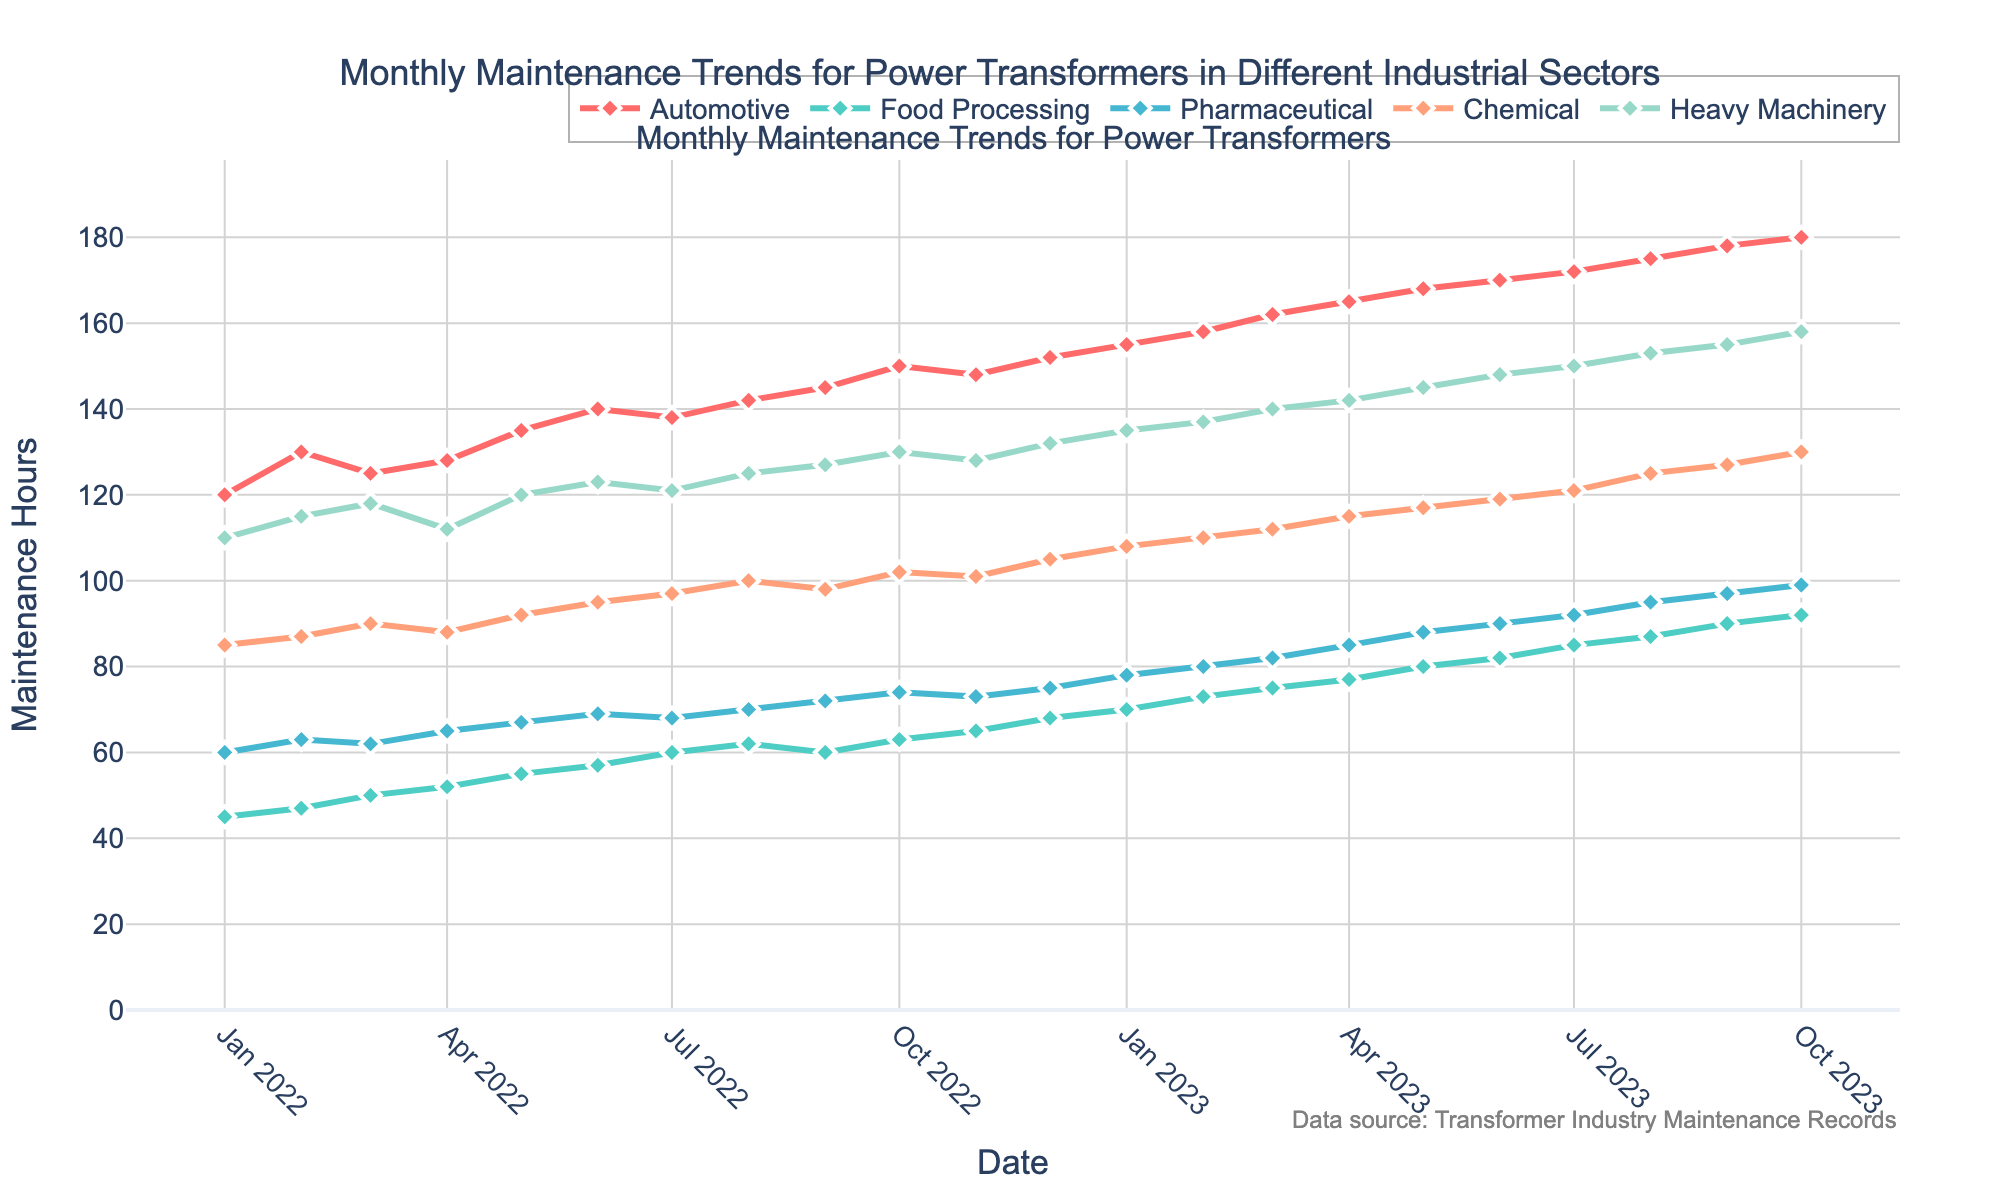what is the title of the plot? The title is usually found at the top of the plot, it is meant to give a concise description of what the plot represents. In this case, we look at the center top of the plot to find it.
Answer: Monthly Maintenance Trends for Power Transformers in Different Industrial Sectors Which sector had the highest maintenance hours in October 2023? To answer this, look at the October 2023 data point and compare the values for each sector. The Automotive sector had a value of 180, which is the highest.
Answer: Automotive Are there any sectors that reduced their maintenance hours from September 2023 to October 2023? By comparing the maintenance hours for each sector in September 2023 and October 2023, we observe that the maintenance hours increased or stayed the same for all sectors.
Answer: No What was the average maintenance hours for the Food Processing sector in 2022? First, sum up the maintenance hours for the Food Processing sector for each month in 2022, then divide by 12 to get the average: (45 + 47 + 50 + 52 + 55 + 57 + 60 + 62 + 60 + 63 + 65 + 68) / 12 = 56.
Answer: 56 How did the maintenance hours for the Heavy Machinery sector change from January 2022 to October 2023? Observe the line corresponding to the Heavy Machinery sector from January 2022 to October 2023. The data shows a general upward trend from 110 in January 2022 to 158 in October 2023.
Answer: Increased In which month did the Pharmaceutical sector experience the highest maintenance hours in 2023? To answer this, review the data points for each month in 2023 for the Pharmaceutical sector. The highest value is in October 2023 with 99 maintenance hours.
Answer: October Compare the overall trend for the Chemical and Food Processing sectors. By examining and comparing both lines over the time period, we see that both sectors display an upward trend, but the Chemical sector consistently has higher maintenance hours than the Food Processing sector.
Answer: Both increased, but Chemical is higher During which months did the Automotive sector see a decrease in maintenance hours? Check each month's data points for the Automotive sector; the months that show decreases are from March 2022 to April 2022 (130 to 125) and from October 2022 to November 2022 (150 to 148).
Answer: March to April 2022, October to November 2022 